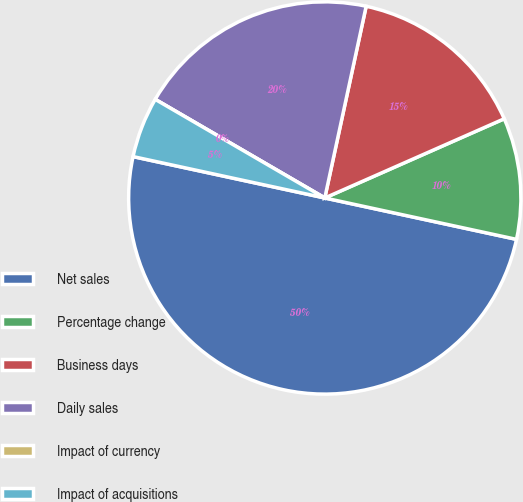Convert chart to OTSL. <chart><loc_0><loc_0><loc_500><loc_500><pie_chart><fcel>Net sales<fcel>Percentage change<fcel>Business days<fcel>Daily sales<fcel>Impact of currency<fcel>Impact of acquisitions<nl><fcel>50.0%<fcel>10.0%<fcel>15.0%<fcel>20.0%<fcel>0.0%<fcel>5.0%<nl></chart> 